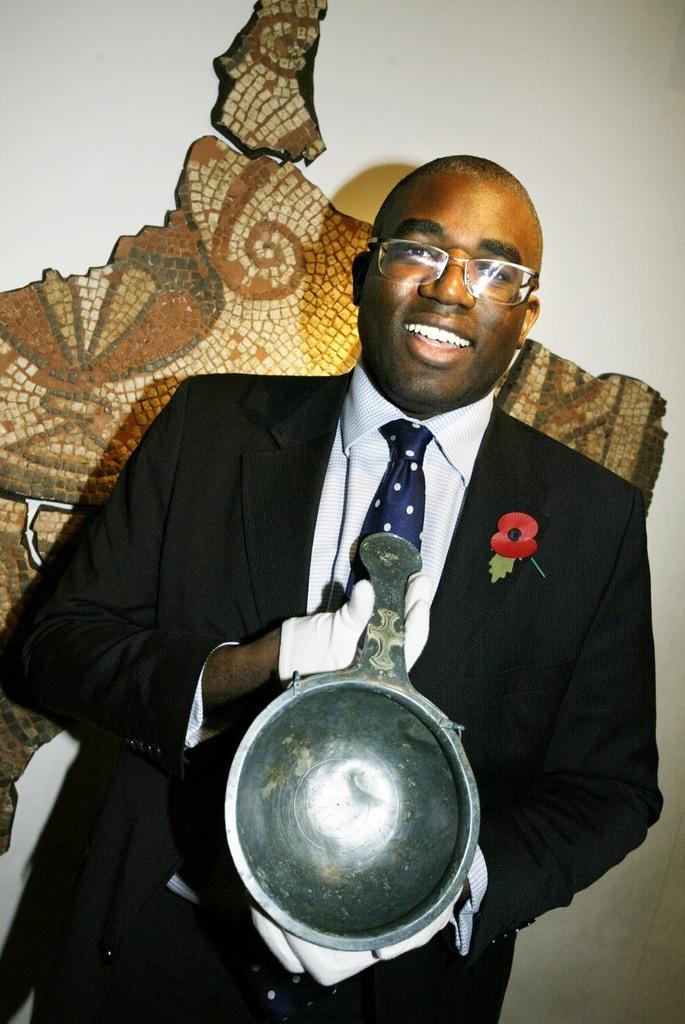How would you summarize this image in a sentence or two? In this picture we can see a person holding an object. In the background there is something on the wall. 